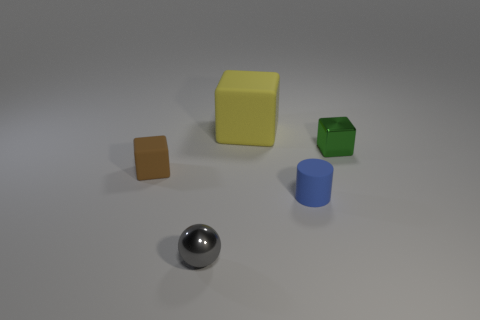Do the small shiny thing right of the small gray ball and the tiny gray metal thing have the same shape? No, the small shiny object and the tiny gray metal thing do not have the same shape. The small shiny object is spherical with a reflective surface, while the tiny gray item appears to be cylindrical with a metallic finish. They differ in both shape and texture. 